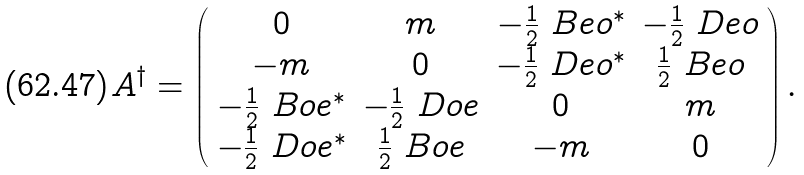Convert formula to latex. <formula><loc_0><loc_0><loc_500><loc_500>A ^ { \dag } = \left ( \begin{array} { c c c c } 0 & m & - \frac { 1 } { 2 } \ B e o ^ { * } & - \frac { 1 } { 2 } \ D e o \\ - m & 0 & - \frac { 1 } { 2 } \ D e o ^ { * } & \frac { 1 } { 2 } \ B e o \\ - \frac { 1 } { 2 } \ B o e ^ { * } & - \frac { 1 } { 2 } \ D o e & 0 & m \\ - \frac { 1 } { 2 } \ D o e ^ { * } & \frac { 1 } { 2 } \ B o e & - m & 0 \end{array} \right ) .</formula> 